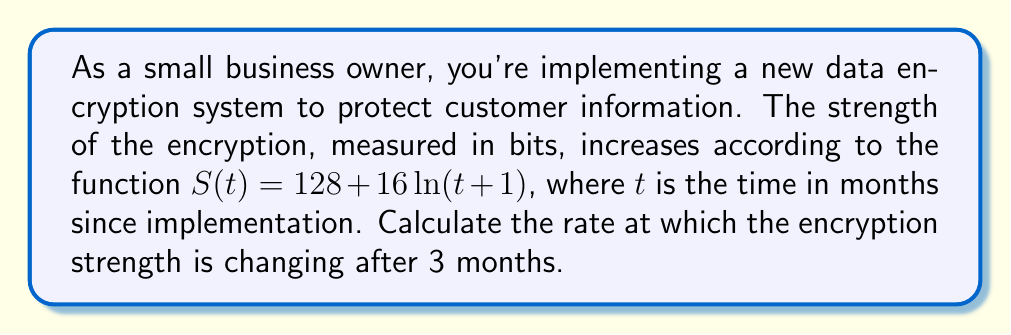Provide a solution to this math problem. To find the rate of change in encryption strength after 3 months, we need to calculate the derivative of $S(t)$ and evaluate it at $t=3$. Here's the step-by-step process:

1) The given function is $S(t) = 128 + 16\ln(t+1)$

2) To find the derivative, we use the chain rule:
   $$\frac{dS}{dt} = 0 + 16 \cdot \frac{d}{dt}[\ln(t+1)]$$

3) The derivative of $\ln(x)$ is $\frac{1}{x}$, so:
   $$\frac{dS}{dt} = 16 \cdot \frac{1}{t+1}$$

4) Simplify:
   $$\frac{dS}{dt} = \frac{16}{t+1}$$

5) Now, we evaluate this at $t=3$:
   $$\left.\frac{dS}{dt}\right|_{t=3} = \frac{16}{3+1} = \frac{16}{4} = 4$$

Therefore, after 3 months, the encryption strength is increasing at a rate of 4 bits per month.
Answer: 4 bits/month 